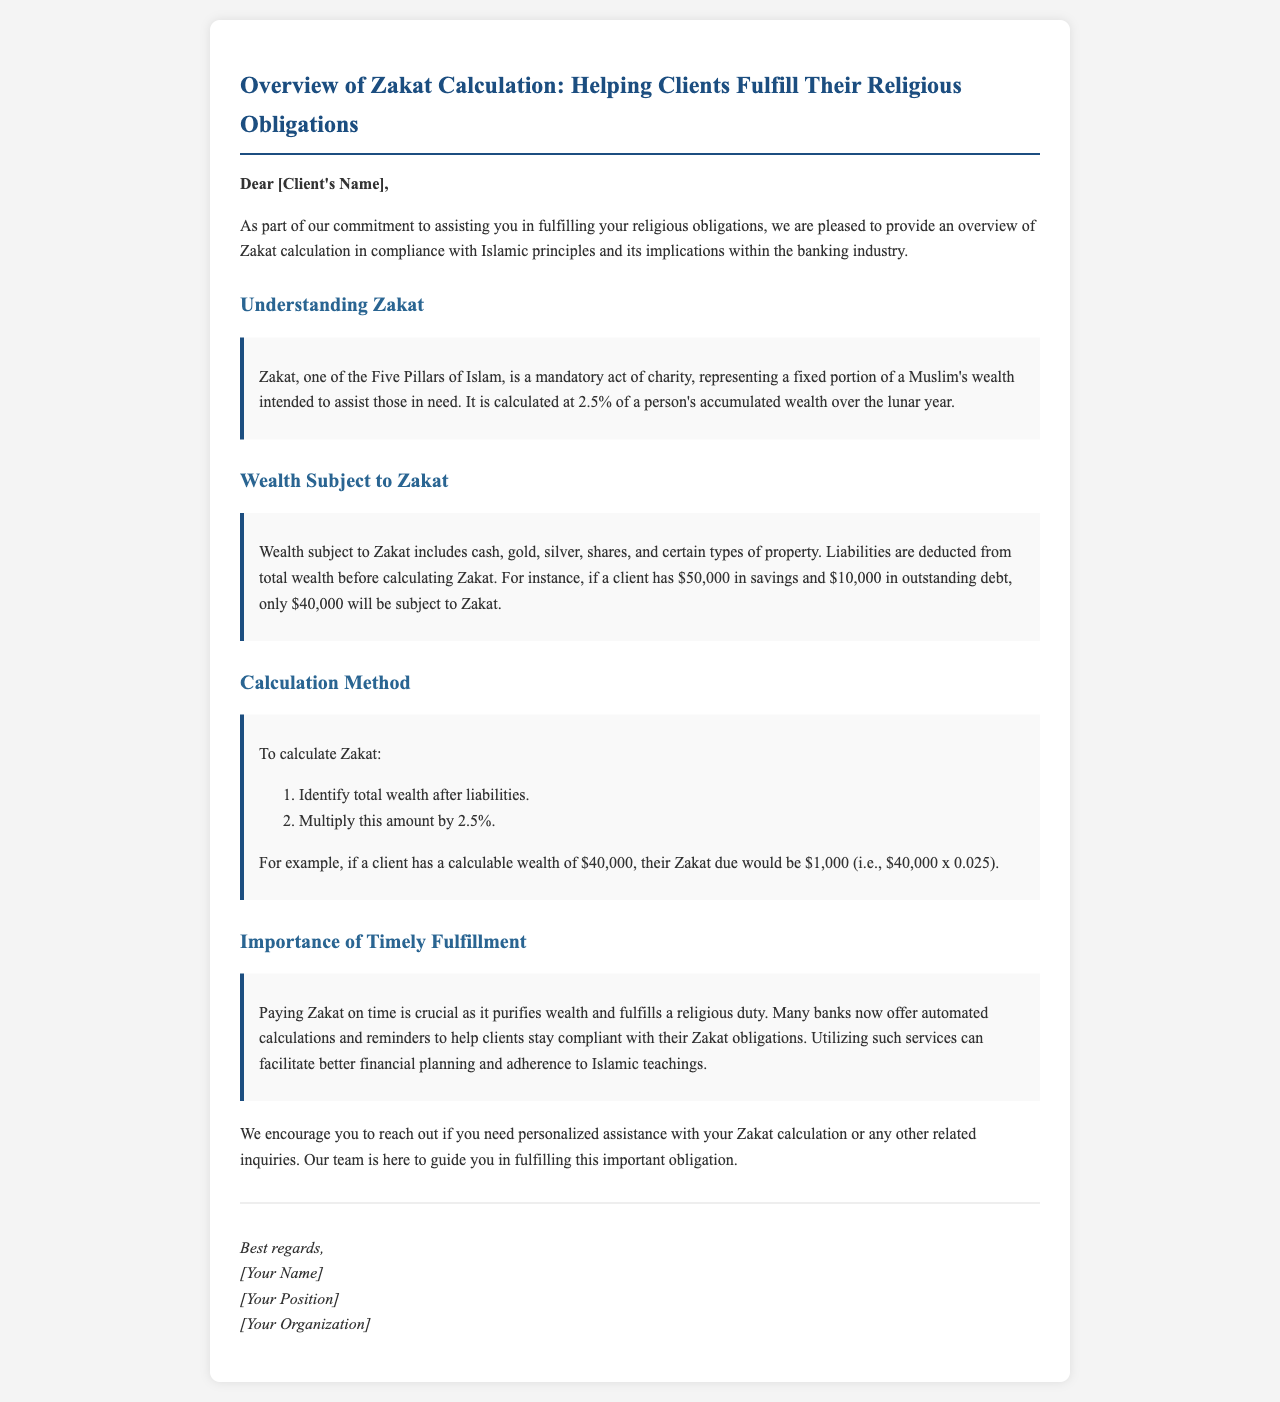What is Zakat? Zakat is described in the document as a mandatory act of charity, representing a fixed portion of a Muslim's wealth intended to assist those in need.
Answer: Mandatory act of charity What percentage of wealth is Zakat? The document specifies the percentage used for Zakat calculation.
Answer: 2.5% What types of wealth are subject to Zakat? The document lists several types of wealth that are subject to Zakat.
Answer: Cash, gold, silver, shares, certain types of property How is Zakat calculated? The document explains the steps to calculate Zakat, which includes identifying total wealth and multiplying by a percentage.
Answer: Identify total wealth after liabilities, multiply by 2.5% If a client has $50,000 in savings and $10,000 in debt, what amount is subject to Zakat? The document provides the calculation of the amount subject to Zakat after deducting liabilities.
Answer: $40,000 What is the importance of timely Zakat payment? The document highlights the importance of timely Zakat payment and its benefits.
Answer: Purifies wealth, fulfills a religious duty Does the document encourage clients to reach out for assistance? The document concludes by inviting clients to seek help with Zakat calculation or inquiries.
Answer: Yes What is the purpose of this email? The document outlines the main topic concerning Zakat calculation and its implications within the banking industry.
Answer: Overview of Zakat calculation 